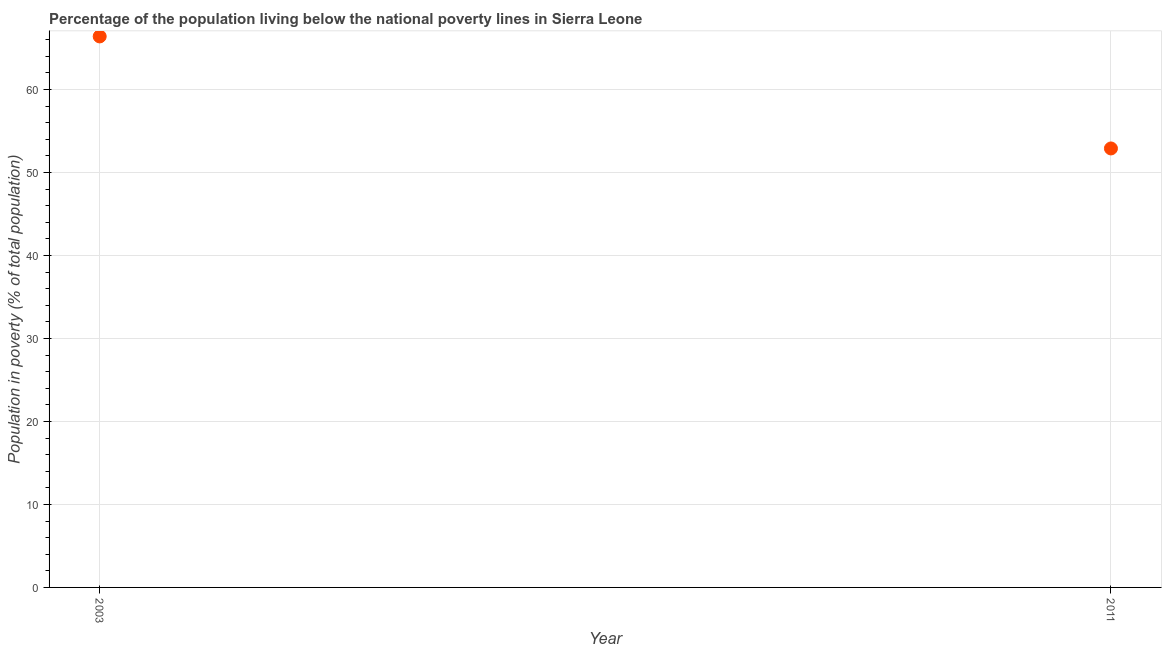What is the percentage of population living below poverty line in 2011?
Offer a very short reply. 52.9. Across all years, what is the maximum percentage of population living below poverty line?
Your answer should be very brief. 66.4. Across all years, what is the minimum percentage of population living below poverty line?
Offer a terse response. 52.9. In which year was the percentage of population living below poverty line maximum?
Ensure brevity in your answer.  2003. What is the sum of the percentage of population living below poverty line?
Your answer should be very brief. 119.3. What is the difference between the percentage of population living below poverty line in 2003 and 2011?
Give a very brief answer. 13.5. What is the average percentage of population living below poverty line per year?
Make the answer very short. 59.65. What is the median percentage of population living below poverty line?
Give a very brief answer. 59.65. In how many years, is the percentage of population living below poverty line greater than 26 %?
Offer a very short reply. 2. Do a majority of the years between 2003 and 2011 (inclusive) have percentage of population living below poverty line greater than 34 %?
Provide a short and direct response. Yes. What is the ratio of the percentage of population living below poverty line in 2003 to that in 2011?
Give a very brief answer. 1.26. Is the percentage of population living below poverty line in 2003 less than that in 2011?
Your answer should be compact. No. How many years are there in the graph?
Keep it short and to the point. 2. What is the difference between two consecutive major ticks on the Y-axis?
Ensure brevity in your answer.  10. Are the values on the major ticks of Y-axis written in scientific E-notation?
Keep it short and to the point. No. What is the title of the graph?
Your answer should be very brief. Percentage of the population living below the national poverty lines in Sierra Leone. What is the label or title of the X-axis?
Provide a succinct answer. Year. What is the label or title of the Y-axis?
Give a very brief answer. Population in poverty (% of total population). What is the Population in poverty (% of total population) in 2003?
Provide a short and direct response. 66.4. What is the Population in poverty (% of total population) in 2011?
Offer a very short reply. 52.9. What is the difference between the Population in poverty (% of total population) in 2003 and 2011?
Provide a succinct answer. 13.5. What is the ratio of the Population in poverty (% of total population) in 2003 to that in 2011?
Provide a short and direct response. 1.25. 